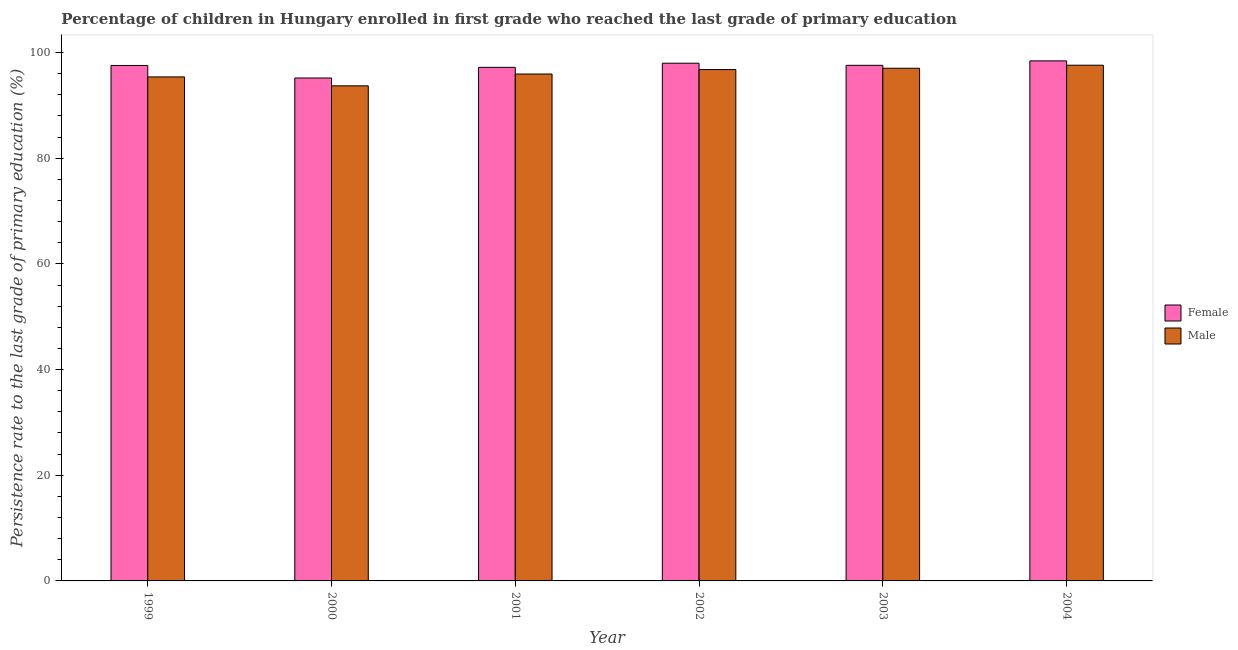How many groups of bars are there?
Your answer should be compact. 6. What is the label of the 3rd group of bars from the left?
Offer a very short reply. 2001. In how many cases, is the number of bars for a given year not equal to the number of legend labels?
Offer a terse response. 0. What is the persistence rate of female students in 1999?
Ensure brevity in your answer.  97.55. Across all years, what is the maximum persistence rate of female students?
Offer a very short reply. 98.42. Across all years, what is the minimum persistence rate of female students?
Ensure brevity in your answer.  95.18. In which year was the persistence rate of male students maximum?
Keep it short and to the point. 2004. What is the total persistence rate of male students in the graph?
Give a very brief answer. 576.42. What is the difference between the persistence rate of female students in 1999 and that in 2000?
Your response must be concise. 2.37. What is the difference between the persistence rate of male students in 2004 and the persistence rate of female students in 1999?
Provide a succinct answer. 2.21. What is the average persistence rate of female students per year?
Keep it short and to the point. 97.32. In how many years, is the persistence rate of male students greater than 64 %?
Your response must be concise. 6. What is the ratio of the persistence rate of male students in 2000 to that in 2004?
Your answer should be compact. 0.96. Is the persistence rate of male students in 2000 less than that in 2002?
Give a very brief answer. Yes. Is the difference between the persistence rate of male students in 1999 and 2002 greater than the difference between the persistence rate of female students in 1999 and 2002?
Your answer should be very brief. No. What is the difference between the highest and the second highest persistence rate of female students?
Ensure brevity in your answer.  0.44. What is the difference between the highest and the lowest persistence rate of male students?
Give a very brief answer. 3.9. In how many years, is the persistence rate of female students greater than the average persistence rate of female students taken over all years?
Your answer should be compact. 4. What does the 2nd bar from the right in 2000 represents?
Your answer should be compact. Female. Are all the bars in the graph horizontal?
Your response must be concise. No. What is the difference between two consecutive major ticks on the Y-axis?
Give a very brief answer. 20. Are the values on the major ticks of Y-axis written in scientific E-notation?
Give a very brief answer. No. Does the graph contain any zero values?
Make the answer very short. No. Does the graph contain grids?
Your answer should be very brief. No. What is the title of the graph?
Make the answer very short. Percentage of children in Hungary enrolled in first grade who reached the last grade of primary education. Does "Register a business" appear as one of the legend labels in the graph?
Give a very brief answer. No. What is the label or title of the X-axis?
Give a very brief answer. Year. What is the label or title of the Y-axis?
Your answer should be compact. Persistence rate to the last grade of primary education (%). What is the Persistence rate to the last grade of primary education (%) of Female in 1999?
Keep it short and to the point. 97.55. What is the Persistence rate to the last grade of primary education (%) of Male in 1999?
Give a very brief answer. 95.39. What is the Persistence rate to the last grade of primary education (%) of Female in 2000?
Keep it short and to the point. 95.18. What is the Persistence rate to the last grade of primary education (%) of Male in 2000?
Provide a short and direct response. 93.7. What is the Persistence rate to the last grade of primary education (%) of Female in 2001?
Your response must be concise. 97.19. What is the Persistence rate to the last grade of primary education (%) of Male in 2001?
Provide a short and direct response. 95.94. What is the Persistence rate to the last grade of primary education (%) in Female in 2002?
Ensure brevity in your answer.  97.98. What is the Persistence rate to the last grade of primary education (%) in Male in 2002?
Your answer should be very brief. 96.78. What is the Persistence rate to the last grade of primary education (%) in Female in 2003?
Your response must be concise. 97.58. What is the Persistence rate to the last grade of primary education (%) of Male in 2003?
Offer a very short reply. 97.02. What is the Persistence rate to the last grade of primary education (%) in Female in 2004?
Keep it short and to the point. 98.42. What is the Persistence rate to the last grade of primary education (%) in Male in 2004?
Give a very brief answer. 97.6. Across all years, what is the maximum Persistence rate to the last grade of primary education (%) in Female?
Provide a short and direct response. 98.42. Across all years, what is the maximum Persistence rate to the last grade of primary education (%) in Male?
Your answer should be compact. 97.6. Across all years, what is the minimum Persistence rate to the last grade of primary education (%) of Female?
Ensure brevity in your answer.  95.18. Across all years, what is the minimum Persistence rate to the last grade of primary education (%) in Male?
Make the answer very short. 93.7. What is the total Persistence rate to the last grade of primary education (%) in Female in the graph?
Make the answer very short. 583.91. What is the total Persistence rate to the last grade of primary education (%) of Male in the graph?
Offer a terse response. 576.42. What is the difference between the Persistence rate to the last grade of primary education (%) in Female in 1999 and that in 2000?
Your response must be concise. 2.37. What is the difference between the Persistence rate to the last grade of primary education (%) of Male in 1999 and that in 2000?
Make the answer very short. 1.69. What is the difference between the Persistence rate to the last grade of primary education (%) in Female in 1999 and that in 2001?
Your response must be concise. 0.36. What is the difference between the Persistence rate to the last grade of primary education (%) of Male in 1999 and that in 2001?
Your response must be concise. -0.55. What is the difference between the Persistence rate to the last grade of primary education (%) of Female in 1999 and that in 2002?
Offer a terse response. -0.42. What is the difference between the Persistence rate to the last grade of primary education (%) of Male in 1999 and that in 2002?
Ensure brevity in your answer.  -1.39. What is the difference between the Persistence rate to the last grade of primary education (%) in Female in 1999 and that in 2003?
Keep it short and to the point. -0.03. What is the difference between the Persistence rate to the last grade of primary education (%) in Male in 1999 and that in 2003?
Ensure brevity in your answer.  -1.64. What is the difference between the Persistence rate to the last grade of primary education (%) in Female in 1999 and that in 2004?
Provide a succinct answer. -0.87. What is the difference between the Persistence rate to the last grade of primary education (%) in Male in 1999 and that in 2004?
Provide a short and direct response. -2.21. What is the difference between the Persistence rate to the last grade of primary education (%) of Female in 2000 and that in 2001?
Your answer should be very brief. -2.01. What is the difference between the Persistence rate to the last grade of primary education (%) of Male in 2000 and that in 2001?
Keep it short and to the point. -2.24. What is the difference between the Persistence rate to the last grade of primary education (%) in Female in 2000 and that in 2002?
Provide a succinct answer. -2.8. What is the difference between the Persistence rate to the last grade of primary education (%) of Male in 2000 and that in 2002?
Make the answer very short. -3.08. What is the difference between the Persistence rate to the last grade of primary education (%) of Female in 2000 and that in 2003?
Your answer should be compact. -2.4. What is the difference between the Persistence rate to the last grade of primary education (%) of Male in 2000 and that in 2003?
Provide a short and direct response. -3.33. What is the difference between the Persistence rate to the last grade of primary education (%) in Female in 2000 and that in 2004?
Ensure brevity in your answer.  -3.24. What is the difference between the Persistence rate to the last grade of primary education (%) of Male in 2000 and that in 2004?
Your response must be concise. -3.9. What is the difference between the Persistence rate to the last grade of primary education (%) of Female in 2001 and that in 2002?
Give a very brief answer. -0.78. What is the difference between the Persistence rate to the last grade of primary education (%) of Male in 2001 and that in 2002?
Your answer should be very brief. -0.84. What is the difference between the Persistence rate to the last grade of primary education (%) in Female in 2001 and that in 2003?
Give a very brief answer. -0.39. What is the difference between the Persistence rate to the last grade of primary education (%) in Male in 2001 and that in 2003?
Provide a short and direct response. -1.09. What is the difference between the Persistence rate to the last grade of primary education (%) of Female in 2001 and that in 2004?
Your answer should be compact. -1.23. What is the difference between the Persistence rate to the last grade of primary education (%) of Male in 2001 and that in 2004?
Your answer should be very brief. -1.66. What is the difference between the Persistence rate to the last grade of primary education (%) in Female in 2002 and that in 2003?
Offer a very short reply. 0.4. What is the difference between the Persistence rate to the last grade of primary education (%) of Male in 2002 and that in 2003?
Offer a terse response. -0.24. What is the difference between the Persistence rate to the last grade of primary education (%) in Female in 2002 and that in 2004?
Your response must be concise. -0.44. What is the difference between the Persistence rate to the last grade of primary education (%) in Male in 2002 and that in 2004?
Offer a terse response. -0.82. What is the difference between the Persistence rate to the last grade of primary education (%) of Female in 2003 and that in 2004?
Offer a very short reply. -0.84. What is the difference between the Persistence rate to the last grade of primary education (%) of Male in 2003 and that in 2004?
Your response must be concise. -0.58. What is the difference between the Persistence rate to the last grade of primary education (%) of Female in 1999 and the Persistence rate to the last grade of primary education (%) of Male in 2000?
Make the answer very short. 3.86. What is the difference between the Persistence rate to the last grade of primary education (%) of Female in 1999 and the Persistence rate to the last grade of primary education (%) of Male in 2001?
Your response must be concise. 1.62. What is the difference between the Persistence rate to the last grade of primary education (%) of Female in 1999 and the Persistence rate to the last grade of primary education (%) of Male in 2002?
Provide a short and direct response. 0.78. What is the difference between the Persistence rate to the last grade of primary education (%) in Female in 1999 and the Persistence rate to the last grade of primary education (%) in Male in 2003?
Offer a very short reply. 0.53. What is the difference between the Persistence rate to the last grade of primary education (%) in Female in 1999 and the Persistence rate to the last grade of primary education (%) in Male in 2004?
Give a very brief answer. -0.04. What is the difference between the Persistence rate to the last grade of primary education (%) in Female in 2000 and the Persistence rate to the last grade of primary education (%) in Male in 2001?
Give a very brief answer. -0.76. What is the difference between the Persistence rate to the last grade of primary education (%) of Female in 2000 and the Persistence rate to the last grade of primary education (%) of Male in 2002?
Provide a short and direct response. -1.6. What is the difference between the Persistence rate to the last grade of primary education (%) of Female in 2000 and the Persistence rate to the last grade of primary education (%) of Male in 2003?
Keep it short and to the point. -1.84. What is the difference between the Persistence rate to the last grade of primary education (%) of Female in 2000 and the Persistence rate to the last grade of primary education (%) of Male in 2004?
Ensure brevity in your answer.  -2.42. What is the difference between the Persistence rate to the last grade of primary education (%) of Female in 2001 and the Persistence rate to the last grade of primary education (%) of Male in 2002?
Keep it short and to the point. 0.42. What is the difference between the Persistence rate to the last grade of primary education (%) of Female in 2001 and the Persistence rate to the last grade of primary education (%) of Male in 2003?
Make the answer very short. 0.17. What is the difference between the Persistence rate to the last grade of primary education (%) of Female in 2001 and the Persistence rate to the last grade of primary education (%) of Male in 2004?
Ensure brevity in your answer.  -0.4. What is the difference between the Persistence rate to the last grade of primary education (%) in Female in 2002 and the Persistence rate to the last grade of primary education (%) in Male in 2003?
Offer a very short reply. 0.95. What is the difference between the Persistence rate to the last grade of primary education (%) of Female in 2002 and the Persistence rate to the last grade of primary education (%) of Male in 2004?
Make the answer very short. 0.38. What is the difference between the Persistence rate to the last grade of primary education (%) of Female in 2003 and the Persistence rate to the last grade of primary education (%) of Male in 2004?
Provide a short and direct response. -0.02. What is the average Persistence rate to the last grade of primary education (%) in Female per year?
Your answer should be very brief. 97.32. What is the average Persistence rate to the last grade of primary education (%) of Male per year?
Your response must be concise. 96.07. In the year 1999, what is the difference between the Persistence rate to the last grade of primary education (%) of Female and Persistence rate to the last grade of primary education (%) of Male?
Offer a terse response. 2.17. In the year 2000, what is the difference between the Persistence rate to the last grade of primary education (%) in Female and Persistence rate to the last grade of primary education (%) in Male?
Provide a succinct answer. 1.49. In the year 2001, what is the difference between the Persistence rate to the last grade of primary education (%) in Female and Persistence rate to the last grade of primary education (%) in Male?
Offer a very short reply. 1.26. In the year 2002, what is the difference between the Persistence rate to the last grade of primary education (%) of Female and Persistence rate to the last grade of primary education (%) of Male?
Your answer should be very brief. 1.2. In the year 2003, what is the difference between the Persistence rate to the last grade of primary education (%) of Female and Persistence rate to the last grade of primary education (%) of Male?
Offer a very short reply. 0.56. In the year 2004, what is the difference between the Persistence rate to the last grade of primary education (%) of Female and Persistence rate to the last grade of primary education (%) of Male?
Your answer should be very brief. 0.82. What is the ratio of the Persistence rate to the last grade of primary education (%) in Female in 1999 to that in 2000?
Ensure brevity in your answer.  1.02. What is the ratio of the Persistence rate to the last grade of primary education (%) of Male in 1999 to that in 2001?
Make the answer very short. 0.99. What is the ratio of the Persistence rate to the last grade of primary education (%) of Female in 1999 to that in 2002?
Offer a terse response. 1. What is the ratio of the Persistence rate to the last grade of primary education (%) of Male in 1999 to that in 2002?
Offer a very short reply. 0.99. What is the ratio of the Persistence rate to the last grade of primary education (%) in Female in 1999 to that in 2003?
Offer a very short reply. 1. What is the ratio of the Persistence rate to the last grade of primary education (%) of Male in 1999 to that in 2003?
Keep it short and to the point. 0.98. What is the ratio of the Persistence rate to the last grade of primary education (%) in Male in 1999 to that in 2004?
Your answer should be compact. 0.98. What is the ratio of the Persistence rate to the last grade of primary education (%) of Female in 2000 to that in 2001?
Provide a succinct answer. 0.98. What is the ratio of the Persistence rate to the last grade of primary education (%) in Male in 2000 to that in 2001?
Keep it short and to the point. 0.98. What is the ratio of the Persistence rate to the last grade of primary education (%) in Female in 2000 to that in 2002?
Ensure brevity in your answer.  0.97. What is the ratio of the Persistence rate to the last grade of primary education (%) of Male in 2000 to that in 2002?
Ensure brevity in your answer.  0.97. What is the ratio of the Persistence rate to the last grade of primary education (%) in Female in 2000 to that in 2003?
Your answer should be very brief. 0.98. What is the ratio of the Persistence rate to the last grade of primary education (%) of Male in 2000 to that in 2003?
Keep it short and to the point. 0.97. What is the ratio of the Persistence rate to the last grade of primary education (%) in Female in 2000 to that in 2004?
Offer a very short reply. 0.97. What is the ratio of the Persistence rate to the last grade of primary education (%) of Female in 2001 to that in 2003?
Give a very brief answer. 1. What is the ratio of the Persistence rate to the last grade of primary education (%) of Female in 2001 to that in 2004?
Ensure brevity in your answer.  0.99. What is the ratio of the Persistence rate to the last grade of primary education (%) in Female in 2002 to that in 2003?
Keep it short and to the point. 1. What is the ratio of the Persistence rate to the last grade of primary education (%) in Male in 2002 to that in 2004?
Ensure brevity in your answer.  0.99. What is the ratio of the Persistence rate to the last grade of primary education (%) in Female in 2003 to that in 2004?
Give a very brief answer. 0.99. What is the ratio of the Persistence rate to the last grade of primary education (%) in Male in 2003 to that in 2004?
Offer a very short reply. 0.99. What is the difference between the highest and the second highest Persistence rate to the last grade of primary education (%) in Female?
Provide a succinct answer. 0.44. What is the difference between the highest and the second highest Persistence rate to the last grade of primary education (%) in Male?
Your answer should be very brief. 0.58. What is the difference between the highest and the lowest Persistence rate to the last grade of primary education (%) in Female?
Offer a very short reply. 3.24. What is the difference between the highest and the lowest Persistence rate to the last grade of primary education (%) in Male?
Ensure brevity in your answer.  3.9. 